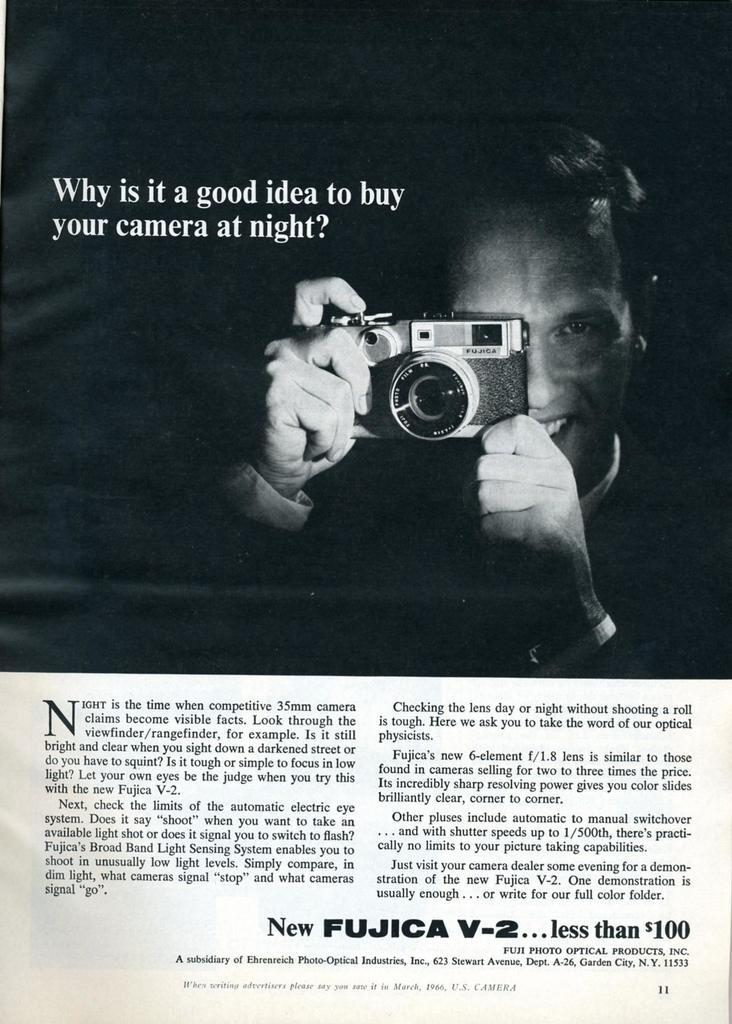What is the main subject of the image? The main subject of the image is a poster with text on it. What else can be seen in the image besides the poster? There is a man in the image. What is the man doing in the image? The man is holding a camera and clicking pictures with it. What type of reward is the man receiving for swimming in the image? There is no swimming or reward present in the image; it features a man holding a camera and clicking pictures. What kind of cart is the man using to transport his camera in the image? There is no cart present in the image; the man is holding the camera in his hands. 